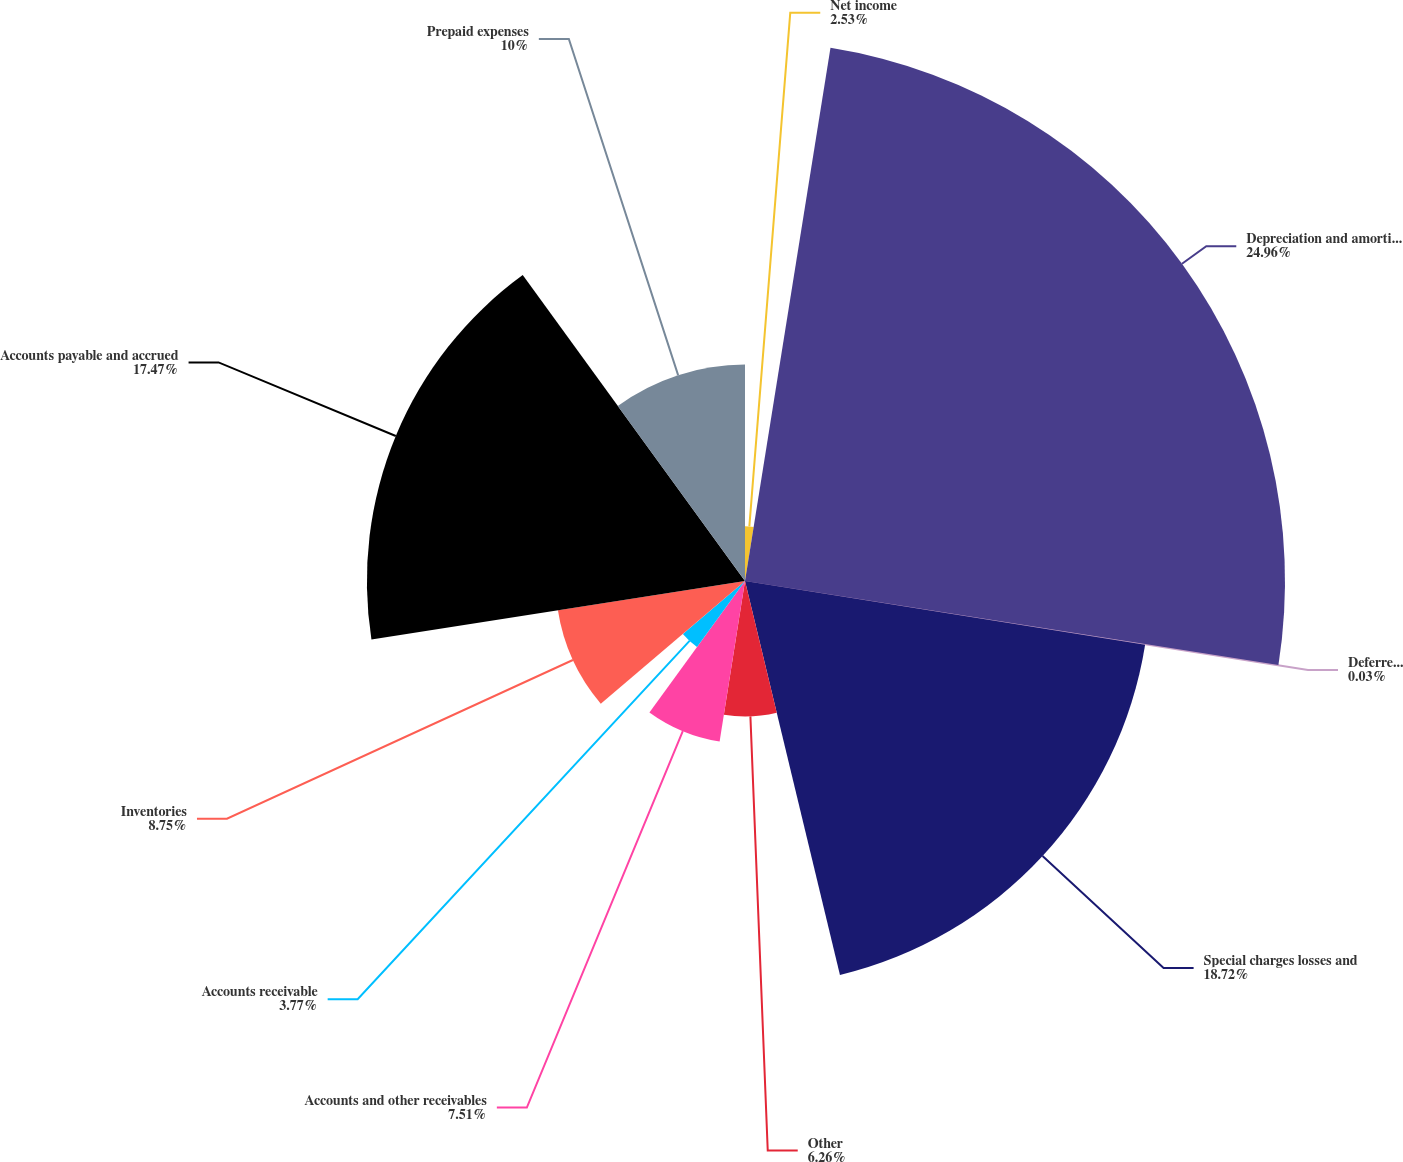Convert chart. <chart><loc_0><loc_0><loc_500><loc_500><pie_chart><fcel>Net income<fcel>Depreciation and amortization<fcel>Deferred income taxes<fcel>Special charges losses and<fcel>Other<fcel>Accounts and other receivables<fcel>Accounts receivable<fcel>Inventories<fcel>Accounts payable and accrued<fcel>Prepaid expenses<nl><fcel>2.53%<fcel>24.95%<fcel>0.03%<fcel>18.72%<fcel>6.26%<fcel>7.51%<fcel>3.77%<fcel>8.75%<fcel>17.47%<fcel>10.0%<nl></chart> 